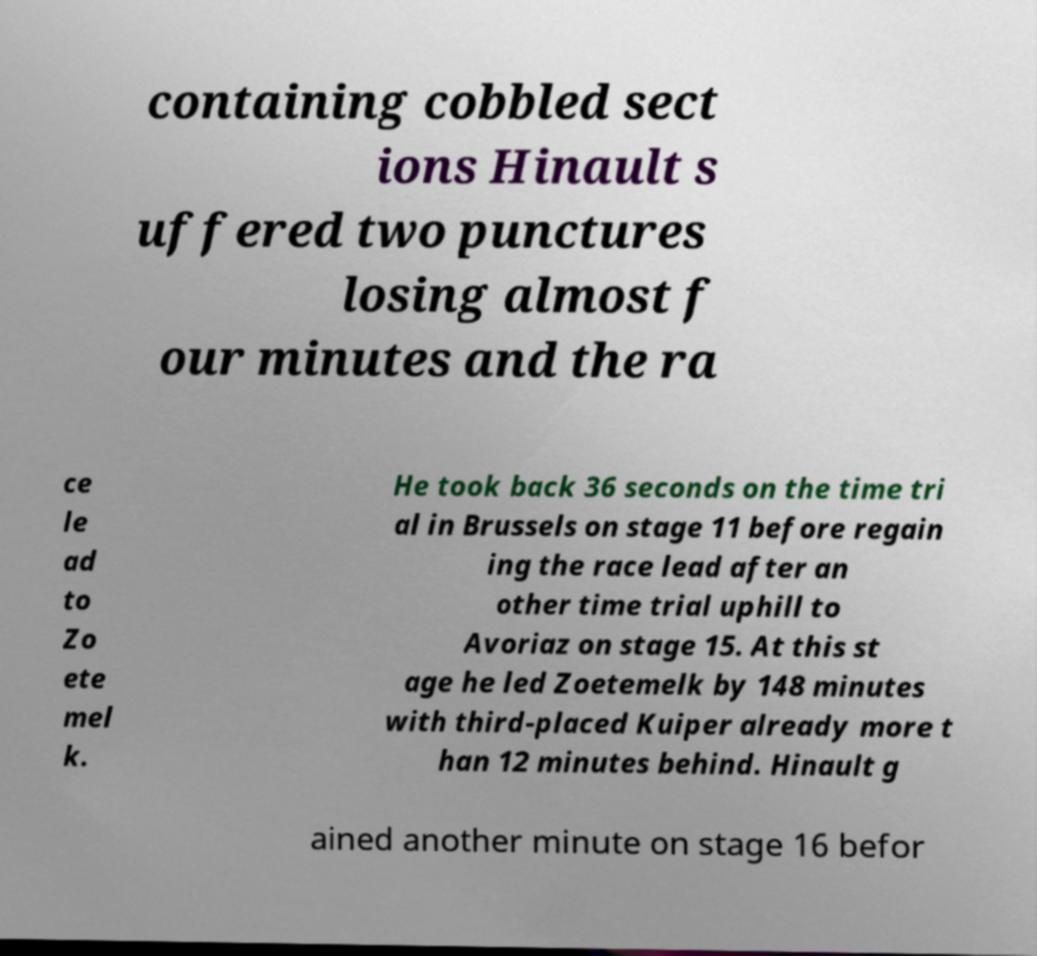There's text embedded in this image that I need extracted. Can you transcribe it verbatim? containing cobbled sect ions Hinault s uffered two punctures losing almost f our minutes and the ra ce le ad to Zo ete mel k. He took back 36 seconds on the time tri al in Brussels on stage 11 before regain ing the race lead after an other time trial uphill to Avoriaz on stage 15. At this st age he led Zoetemelk by 148 minutes with third-placed Kuiper already more t han 12 minutes behind. Hinault g ained another minute on stage 16 befor 